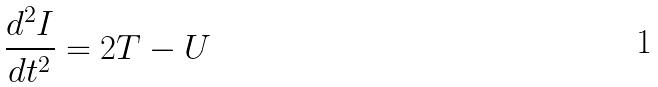<formula> <loc_0><loc_0><loc_500><loc_500>\frac { d ^ { 2 } I } { d t ^ { 2 } } = 2 T - U</formula> 